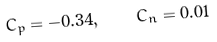Convert formula to latex. <formula><loc_0><loc_0><loc_500><loc_500>C _ { p } = - 0 . 3 4 , \quad C _ { n } = 0 . 0 1</formula> 